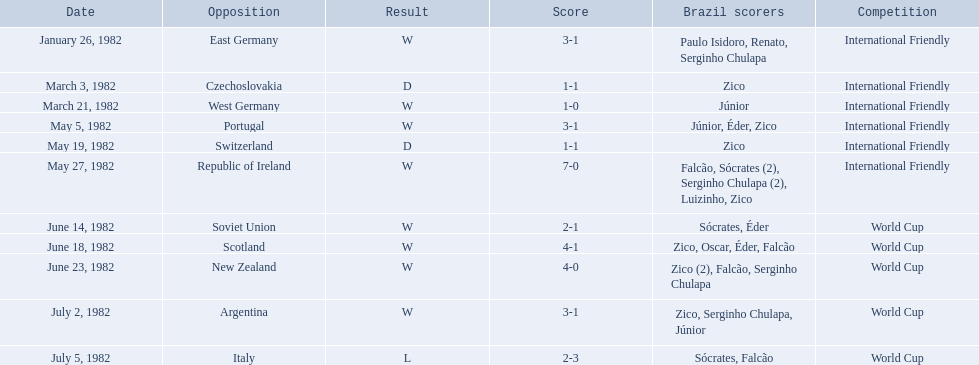What are all the dates of games in 1982 in brazilian football? January 26, 1982, March 3, 1982, March 21, 1982, May 5, 1982, May 19, 1982, May 27, 1982, June 14, 1982, June 18, 1982, June 23, 1982, July 2, 1982, July 5, 1982. Which of these dates is at the top of the chart? January 26, 1982. 